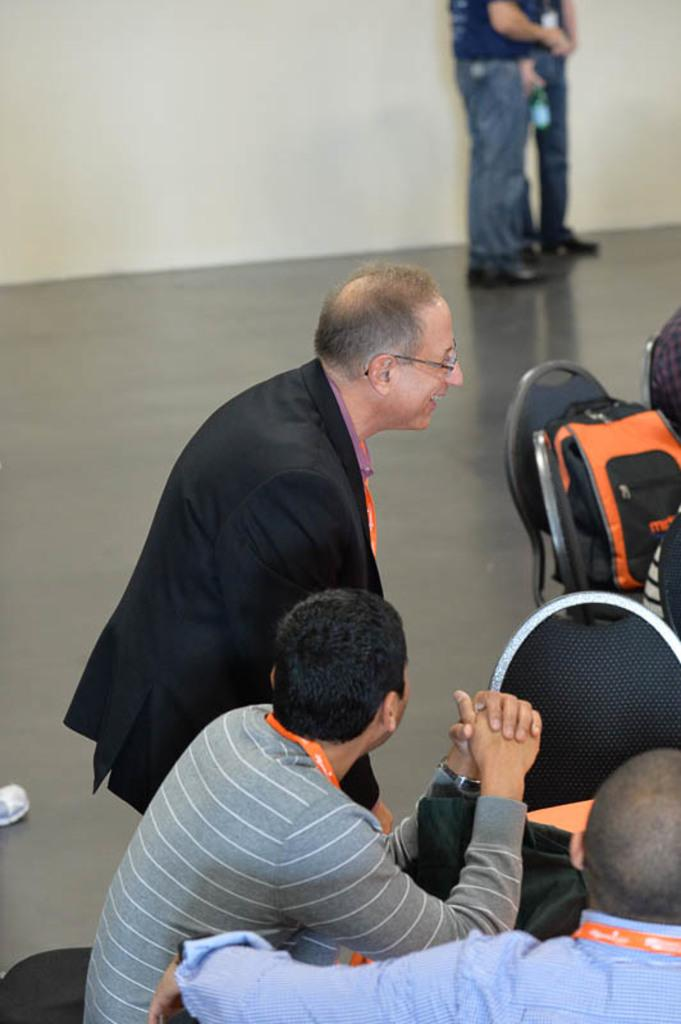How many people are in the image? There are three men in the image. What are the positions of the people in the image? One person is standing, while the rest are sitting. Where are the bags located in the image? The bags are on a chair on the left side of the image. What can be seen in the background of the image? There is a wall in the background of the image, and there are two people in the background as well. What is the name of the judge in the image? There is no judge present in the image. 